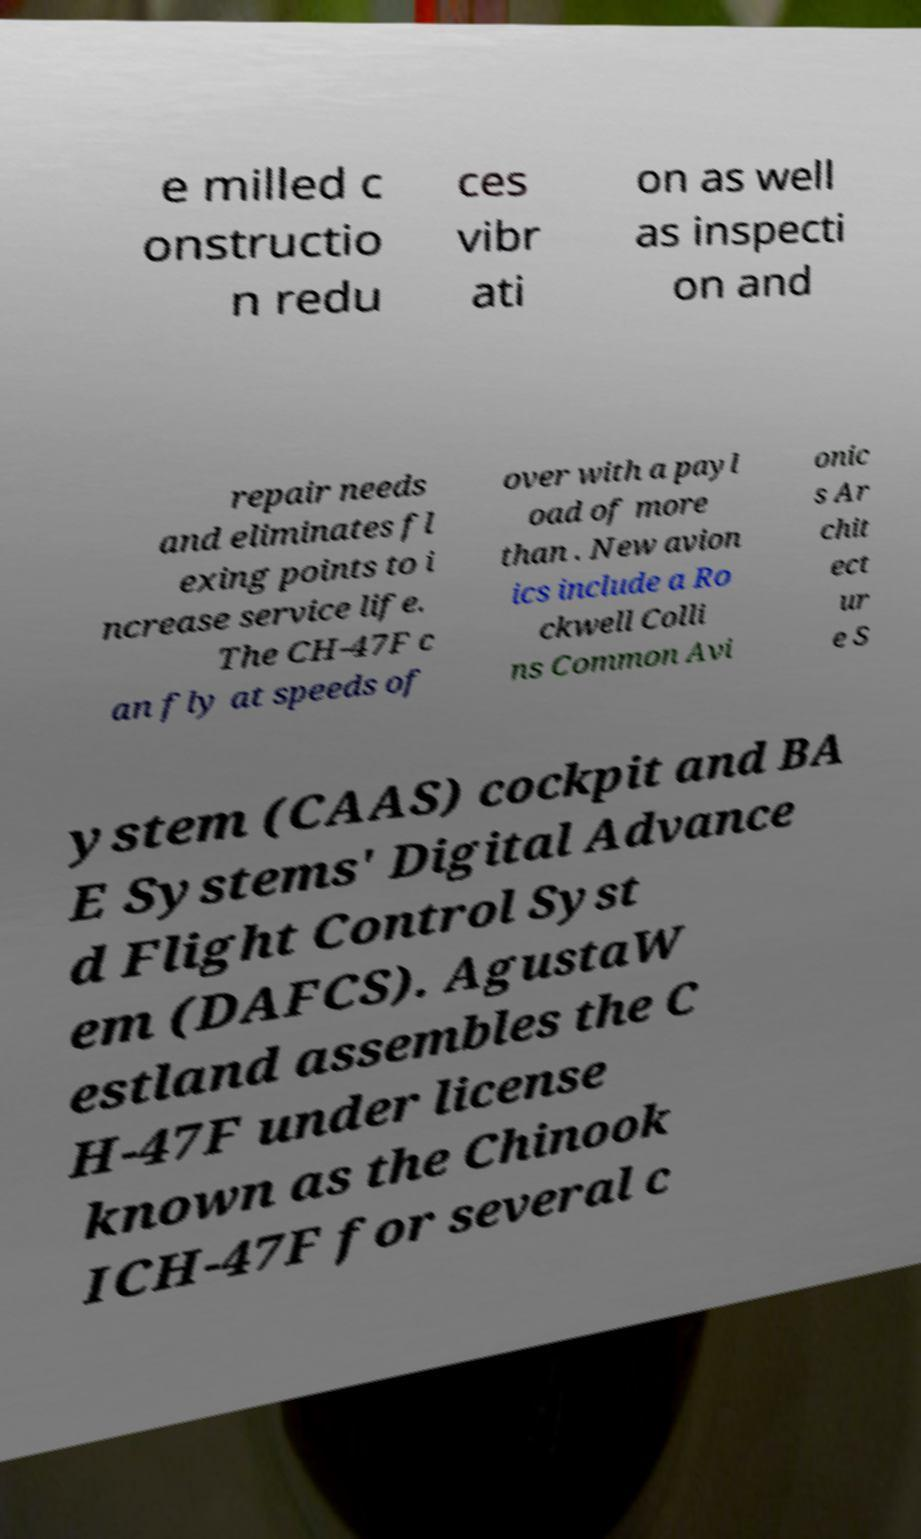Can you accurately transcribe the text from the provided image for me? e milled c onstructio n redu ces vibr ati on as well as inspecti on and repair needs and eliminates fl exing points to i ncrease service life. The CH-47F c an fly at speeds of over with a payl oad of more than . New avion ics include a Ro ckwell Colli ns Common Avi onic s Ar chit ect ur e S ystem (CAAS) cockpit and BA E Systems' Digital Advance d Flight Control Syst em (DAFCS). AgustaW estland assembles the C H-47F under license known as the Chinook ICH-47F for several c 